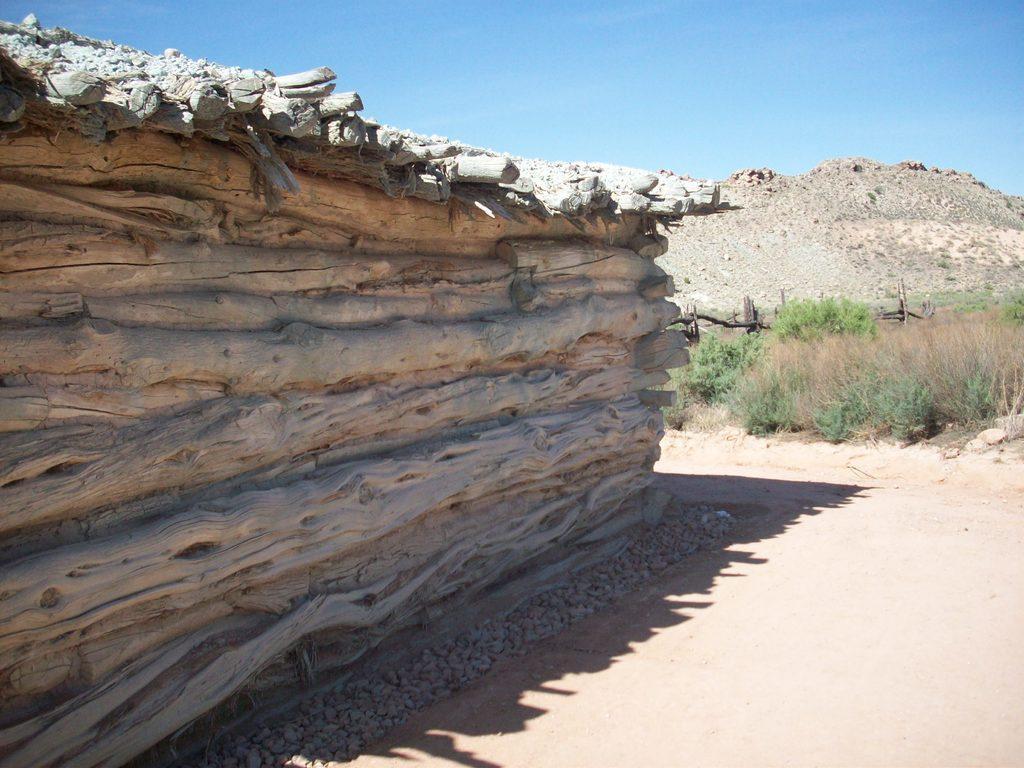Could you give a brief overview of what you see in this image? In this picture we can see stones and it is like a wooden house and behind the house there are plants, hill and a sky. 